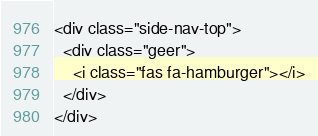Convert code to text. <code><loc_0><loc_0><loc_500><loc_500><_PHP_><div class="side-nav-top">
  <div class="geer">
    <i class="fas fa-hamburger"></i>
  </div>
</div>
</code> 